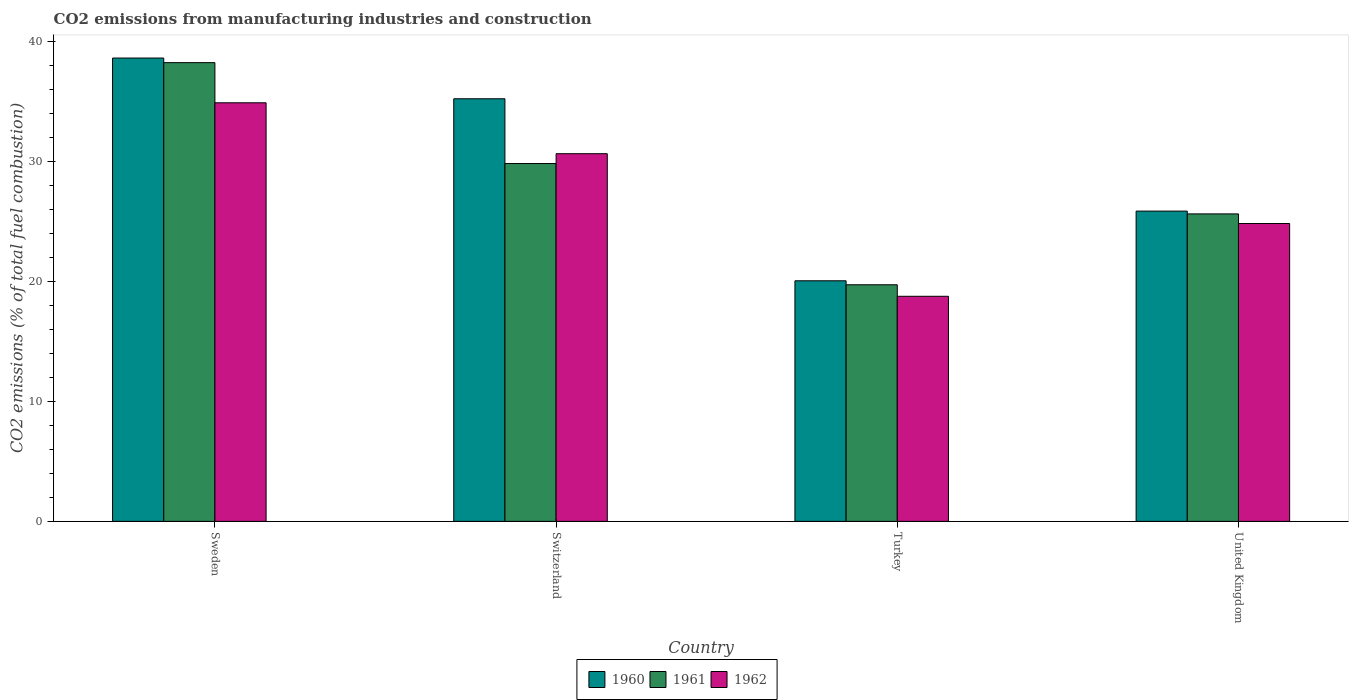Are the number of bars per tick equal to the number of legend labels?
Offer a very short reply. Yes. Are the number of bars on each tick of the X-axis equal?
Your answer should be compact. Yes. How many bars are there on the 4th tick from the right?
Provide a short and direct response. 3. What is the amount of CO2 emitted in 1960 in Sweden?
Keep it short and to the point. 38.61. Across all countries, what is the maximum amount of CO2 emitted in 1960?
Offer a very short reply. 38.61. Across all countries, what is the minimum amount of CO2 emitted in 1962?
Provide a short and direct response. 18.76. In which country was the amount of CO2 emitted in 1962 minimum?
Your response must be concise. Turkey. What is the total amount of CO2 emitted in 1962 in the graph?
Provide a short and direct response. 109.1. What is the difference between the amount of CO2 emitted in 1960 in Turkey and that in United Kingdom?
Provide a succinct answer. -5.81. What is the difference between the amount of CO2 emitted in 1961 in Turkey and the amount of CO2 emitted in 1962 in Switzerland?
Offer a terse response. -10.92. What is the average amount of CO2 emitted in 1961 per country?
Your response must be concise. 28.35. What is the difference between the amount of CO2 emitted of/in 1962 and amount of CO2 emitted of/in 1961 in United Kingdom?
Provide a short and direct response. -0.8. In how many countries, is the amount of CO2 emitted in 1960 greater than 8 %?
Offer a very short reply. 4. What is the ratio of the amount of CO2 emitted in 1962 in Sweden to that in Turkey?
Keep it short and to the point. 1.86. Is the amount of CO2 emitted in 1962 in Sweden less than that in United Kingdom?
Your response must be concise. No. What is the difference between the highest and the second highest amount of CO2 emitted in 1960?
Your answer should be very brief. -9.36. What is the difference between the highest and the lowest amount of CO2 emitted in 1961?
Provide a short and direct response. 18.51. What does the 1st bar from the right in Switzerland represents?
Make the answer very short. 1962. Is it the case that in every country, the sum of the amount of CO2 emitted in 1960 and amount of CO2 emitted in 1961 is greater than the amount of CO2 emitted in 1962?
Your response must be concise. Yes. What is the difference between two consecutive major ticks on the Y-axis?
Keep it short and to the point. 10. Are the values on the major ticks of Y-axis written in scientific E-notation?
Make the answer very short. No. Does the graph contain grids?
Keep it short and to the point. No. Where does the legend appear in the graph?
Keep it short and to the point. Bottom center. How many legend labels are there?
Give a very brief answer. 3. How are the legend labels stacked?
Provide a succinct answer. Horizontal. What is the title of the graph?
Ensure brevity in your answer.  CO2 emissions from manufacturing industries and construction. Does "2001" appear as one of the legend labels in the graph?
Make the answer very short. No. What is the label or title of the Y-axis?
Offer a very short reply. CO2 emissions (% of total fuel combustion). What is the CO2 emissions (% of total fuel combustion) in 1960 in Sweden?
Offer a terse response. 38.61. What is the CO2 emissions (% of total fuel combustion) in 1961 in Sweden?
Your answer should be very brief. 38.23. What is the CO2 emissions (% of total fuel combustion) of 1962 in Sweden?
Keep it short and to the point. 34.88. What is the CO2 emissions (% of total fuel combustion) of 1960 in Switzerland?
Keep it short and to the point. 35.22. What is the CO2 emissions (% of total fuel combustion) in 1961 in Switzerland?
Offer a terse response. 29.82. What is the CO2 emissions (% of total fuel combustion) in 1962 in Switzerland?
Provide a succinct answer. 30.64. What is the CO2 emissions (% of total fuel combustion) in 1960 in Turkey?
Your answer should be very brief. 20.05. What is the CO2 emissions (% of total fuel combustion) in 1961 in Turkey?
Your answer should be compact. 19.72. What is the CO2 emissions (% of total fuel combustion) of 1962 in Turkey?
Ensure brevity in your answer.  18.76. What is the CO2 emissions (% of total fuel combustion) of 1960 in United Kingdom?
Offer a terse response. 25.86. What is the CO2 emissions (% of total fuel combustion) in 1961 in United Kingdom?
Provide a succinct answer. 25.62. What is the CO2 emissions (% of total fuel combustion) of 1962 in United Kingdom?
Your answer should be compact. 24.82. Across all countries, what is the maximum CO2 emissions (% of total fuel combustion) in 1960?
Offer a terse response. 38.61. Across all countries, what is the maximum CO2 emissions (% of total fuel combustion) of 1961?
Offer a very short reply. 38.23. Across all countries, what is the maximum CO2 emissions (% of total fuel combustion) of 1962?
Make the answer very short. 34.88. Across all countries, what is the minimum CO2 emissions (% of total fuel combustion) of 1960?
Give a very brief answer. 20.05. Across all countries, what is the minimum CO2 emissions (% of total fuel combustion) of 1961?
Ensure brevity in your answer.  19.72. Across all countries, what is the minimum CO2 emissions (% of total fuel combustion) in 1962?
Offer a terse response. 18.76. What is the total CO2 emissions (% of total fuel combustion) of 1960 in the graph?
Give a very brief answer. 119.74. What is the total CO2 emissions (% of total fuel combustion) of 1961 in the graph?
Keep it short and to the point. 113.39. What is the total CO2 emissions (% of total fuel combustion) in 1962 in the graph?
Ensure brevity in your answer.  109.1. What is the difference between the CO2 emissions (% of total fuel combustion) in 1960 in Sweden and that in Switzerland?
Offer a terse response. 3.39. What is the difference between the CO2 emissions (% of total fuel combustion) of 1961 in Sweden and that in Switzerland?
Keep it short and to the point. 8.41. What is the difference between the CO2 emissions (% of total fuel combustion) of 1962 in Sweden and that in Switzerland?
Provide a short and direct response. 4.24. What is the difference between the CO2 emissions (% of total fuel combustion) of 1960 in Sweden and that in Turkey?
Provide a short and direct response. 18.56. What is the difference between the CO2 emissions (% of total fuel combustion) of 1961 in Sweden and that in Turkey?
Keep it short and to the point. 18.51. What is the difference between the CO2 emissions (% of total fuel combustion) of 1962 in Sweden and that in Turkey?
Keep it short and to the point. 16.13. What is the difference between the CO2 emissions (% of total fuel combustion) in 1960 in Sweden and that in United Kingdom?
Make the answer very short. 12.76. What is the difference between the CO2 emissions (% of total fuel combustion) of 1961 in Sweden and that in United Kingdom?
Your answer should be very brief. 12.61. What is the difference between the CO2 emissions (% of total fuel combustion) in 1962 in Sweden and that in United Kingdom?
Your answer should be very brief. 10.06. What is the difference between the CO2 emissions (% of total fuel combustion) of 1960 in Switzerland and that in Turkey?
Keep it short and to the point. 15.17. What is the difference between the CO2 emissions (% of total fuel combustion) in 1961 in Switzerland and that in Turkey?
Provide a short and direct response. 10.1. What is the difference between the CO2 emissions (% of total fuel combustion) in 1962 in Switzerland and that in Turkey?
Your response must be concise. 11.88. What is the difference between the CO2 emissions (% of total fuel combustion) of 1960 in Switzerland and that in United Kingdom?
Your answer should be very brief. 9.36. What is the difference between the CO2 emissions (% of total fuel combustion) in 1961 in Switzerland and that in United Kingdom?
Ensure brevity in your answer.  4.2. What is the difference between the CO2 emissions (% of total fuel combustion) of 1962 in Switzerland and that in United Kingdom?
Provide a succinct answer. 5.82. What is the difference between the CO2 emissions (% of total fuel combustion) in 1960 in Turkey and that in United Kingdom?
Offer a terse response. -5.81. What is the difference between the CO2 emissions (% of total fuel combustion) of 1961 in Turkey and that in United Kingdom?
Keep it short and to the point. -5.91. What is the difference between the CO2 emissions (% of total fuel combustion) in 1962 in Turkey and that in United Kingdom?
Your answer should be compact. -6.06. What is the difference between the CO2 emissions (% of total fuel combustion) in 1960 in Sweden and the CO2 emissions (% of total fuel combustion) in 1961 in Switzerland?
Your answer should be compact. 8.79. What is the difference between the CO2 emissions (% of total fuel combustion) of 1960 in Sweden and the CO2 emissions (% of total fuel combustion) of 1962 in Switzerland?
Offer a very short reply. 7.97. What is the difference between the CO2 emissions (% of total fuel combustion) in 1961 in Sweden and the CO2 emissions (% of total fuel combustion) in 1962 in Switzerland?
Offer a terse response. 7.59. What is the difference between the CO2 emissions (% of total fuel combustion) of 1960 in Sweden and the CO2 emissions (% of total fuel combustion) of 1961 in Turkey?
Your answer should be very brief. 18.9. What is the difference between the CO2 emissions (% of total fuel combustion) of 1960 in Sweden and the CO2 emissions (% of total fuel combustion) of 1962 in Turkey?
Provide a short and direct response. 19.86. What is the difference between the CO2 emissions (% of total fuel combustion) of 1961 in Sweden and the CO2 emissions (% of total fuel combustion) of 1962 in Turkey?
Provide a succinct answer. 19.47. What is the difference between the CO2 emissions (% of total fuel combustion) in 1960 in Sweden and the CO2 emissions (% of total fuel combustion) in 1961 in United Kingdom?
Provide a succinct answer. 12.99. What is the difference between the CO2 emissions (% of total fuel combustion) of 1960 in Sweden and the CO2 emissions (% of total fuel combustion) of 1962 in United Kingdom?
Offer a very short reply. 13.79. What is the difference between the CO2 emissions (% of total fuel combustion) of 1961 in Sweden and the CO2 emissions (% of total fuel combustion) of 1962 in United Kingdom?
Provide a short and direct response. 13.41. What is the difference between the CO2 emissions (% of total fuel combustion) in 1960 in Switzerland and the CO2 emissions (% of total fuel combustion) in 1961 in Turkey?
Your response must be concise. 15.5. What is the difference between the CO2 emissions (% of total fuel combustion) in 1960 in Switzerland and the CO2 emissions (% of total fuel combustion) in 1962 in Turkey?
Offer a very short reply. 16.46. What is the difference between the CO2 emissions (% of total fuel combustion) of 1961 in Switzerland and the CO2 emissions (% of total fuel combustion) of 1962 in Turkey?
Provide a short and direct response. 11.06. What is the difference between the CO2 emissions (% of total fuel combustion) of 1960 in Switzerland and the CO2 emissions (% of total fuel combustion) of 1961 in United Kingdom?
Offer a terse response. 9.6. What is the difference between the CO2 emissions (% of total fuel combustion) in 1960 in Switzerland and the CO2 emissions (% of total fuel combustion) in 1962 in United Kingdom?
Offer a terse response. 10.4. What is the difference between the CO2 emissions (% of total fuel combustion) in 1961 in Switzerland and the CO2 emissions (% of total fuel combustion) in 1962 in United Kingdom?
Provide a succinct answer. 5. What is the difference between the CO2 emissions (% of total fuel combustion) in 1960 in Turkey and the CO2 emissions (% of total fuel combustion) in 1961 in United Kingdom?
Offer a very short reply. -5.57. What is the difference between the CO2 emissions (% of total fuel combustion) in 1960 in Turkey and the CO2 emissions (% of total fuel combustion) in 1962 in United Kingdom?
Your answer should be very brief. -4.77. What is the difference between the CO2 emissions (% of total fuel combustion) of 1961 in Turkey and the CO2 emissions (% of total fuel combustion) of 1962 in United Kingdom?
Provide a short and direct response. -5.11. What is the average CO2 emissions (% of total fuel combustion) of 1960 per country?
Provide a short and direct response. 29.93. What is the average CO2 emissions (% of total fuel combustion) in 1961 per country?
Ensure brevity in your answer.  28.35. What is the average CO2 emissions (% of total fuel combustion) of 1962 per country?
Your answer should be compact. 27.28. What is the difference between the CO2 emissions (% of total fuel combustion) in 1960 and CO2 emissions (% of total fuel combustion) in 1961 in Sweden?
Make the answer very short. 0.38. What is the difference between the CO2 emissions (% of total fuel combustion) in 1960 and CO2 emissions (% of total fuel combustion) in 1962 in Sweden?
Your response must be concise. 3.73. What is the difference between the CO2 emissions (% of total fuel combustion) in 1961 and CO2 emissions (% of total fuel combustion) in 1962 in Sweden?
Ensure brevity in your answer.  3.35. What is the difference between the CO2 emissions (% of total fuel combustion) of 1960 and CO2 emissions (% of total fuel combustion) of 1961 in Switzerland?
Ensure brevity in your answer.  5.4. What is the difference between the CO2 emissions (% of total fuel combustion) of 1960 and CO2 emissions (% of total fuel combustion) of 1962 in Switzerland?
Give a very brief answer. 4.58. What is the difference between the CO2 emissions (% of total fuel combustion) of 1961 and CO2 emissions (% of total fuel combustion) of 1962 in Switzerland?
Your response must be concise. -0.82. What is the difference between the CO2 emissions (% of total fuel combustion) of 1960 and CO2 emissions (% of total fuel combustion) of 1961 in Turkey?
Ensure brevity in your answer.  0.33. What is the difference between the CO2 emissions (% of total fuel combustion) of 1960 and CO2 emissions (% of total fuel combustion) of 1962 in Turkey?
Your answer should be compact. 1.29. What is the difference between the CO2 emissions (% of total fuel combustion) in 1961 and CO2 emissions (% of total fuel combustion) in 1962 in Turkey?
Provide a succinct answer. 0.96. What is the difference between the CO2 emissions (% of total fuel combustion) in 1960 and CO2 emissions (% of total fuel combustion) in 1961 in United Kingdom?
Your answer should be very brief. 0.23. What is the difference between the CO2 emissions (% of total fuel combustion) in 1960 and CO2 emissions (% of total fuel combustion) in 1962 in United Kingdom?
Make the answer very short. 1.03. What is the difference between the CO2 emissions (% of total fuel combustion) of 1961 and CO2 emissions (% of total fuel combustion) of 1962 in United Kingdom?
Ensure brevity in your answer.  0.8. What is the ratio of the CO2 emissions (% of total fuel combustion) in 1960 in Sweden to that in Switzerland?
Offer a terse response. 1.1. What is the ratio of the CO2 emissions (% of total fuel combustion) of 1961 in Sweden to that in Switzerland?
Your response must be concise. 1.28. What is the ratio of the CO2 emissions (% of total fuel combustion) of 1962 in Sweden to that in Switzerland?
Keep it short and to the point. 1.14. What is the ratio of the CO2 emissions (% of total fuel combustion) in 1960 in Sweden to that in Turkey?
Ensure brevity in your answer.  1.93. What is the ratio of the CO2 emissions (% of total fuel combustion) of 1961 in Sweden to that in Turkey?
Your answer should be very brief. 1.94. What is the ratio of the CO2 emissions (% of total fuel combustion) in 1962 in Sweden to that in Turkey?
Provide a short and direct response. 1.86. What is the ratio of the CO2 emissions (% of total fuel combustion) of 1960 in Sweden to that in United Kingdom?
Provide a short and direct response. 1.49. What is the ratio of the CO2 emissions (% of total fuel combustion) of 1961 in Sweden to that in United Kingdom?
Provide a succinct answer. 1.49. What is the ratio of the CO2 emissions (% of total fuel combustion) of 1962 in Sweden to that in United Kingdom?
Offer a very short reply. 1.41. What is the ratio of the CO2 emissions (% of total fuel combustion) in 1960 in Switzerland to that in Turkey?
Provide a succinct answer. 1.76. What is the ratio of the CO2 emissions (% of total fuel combustion) of 1961 in Switzerland to that in Turkey?
Give a very brief answer. 1.51. What is the ratio of the CO2 emissions (% of total fuel combustion) of 1962 in Switzerland to that in Turkey?
Give a very brief answer. 1.63. What is the ratio of the CO2 emissions (% of total fuel combustion) of 1960 in Switzerland to that in United Kingdom?
Provide a succinct answer. 1.36. What is the ratio of the CO2 emissions (% of total fuel combustion) in 1961 in Switzerland to that in United Kingdom?
Your answer should be compact. 1.16. What is the ratio of the CO2 emissions (% of total fuel combustion) in 1962 in Switzerland to that in United Kingdom?
Make the answer very short. 1.23. What is the ratio of the CO2 emissions (% of total fuel combustion) in 1960 in Turkey to that in United Kingdom?
Keep it short and to the point. 0.78. What is the ratio of the CO2 emissions (% of total fuel combustion) in 1961 in Turkey to that in United Kingdom?
Provide a short and direct response. 0.77. What is the ratio of the CO2 emissions (% of total fuel combustion) of 1962 in Turkey to that in United Kingdom?
Offer a terse response. 0.76. What is the difference between the highest and the second highest CO2 emissions (% of total fuel combustion) in 1960?
Provide a succinct answer. 3.39. What is the difference between the highest and the second highest CO2 emissions (% of total fuel combustion) of 1961?
Give a very brief answer. 8.41. What is the difference between the highest and the second highest CO2 emissions (% of total fuel combustion) of 1962?
Offer a terse response. 4.24. What is the difference between the highest and the lowest CO2 emissions (% of total fuel combustion) of 1960?
Give a very brief answer. 18.56. What is the difference between the highest and the lowest CO2 emissions (% of total fuel combustion) in 1961?
Provide a succinct answer. 18.51. What is the difference between the highest and the lowest CO2 emissions (% of total fuel combustion) in 1962?
Provide a succinct answer. 16.13. 